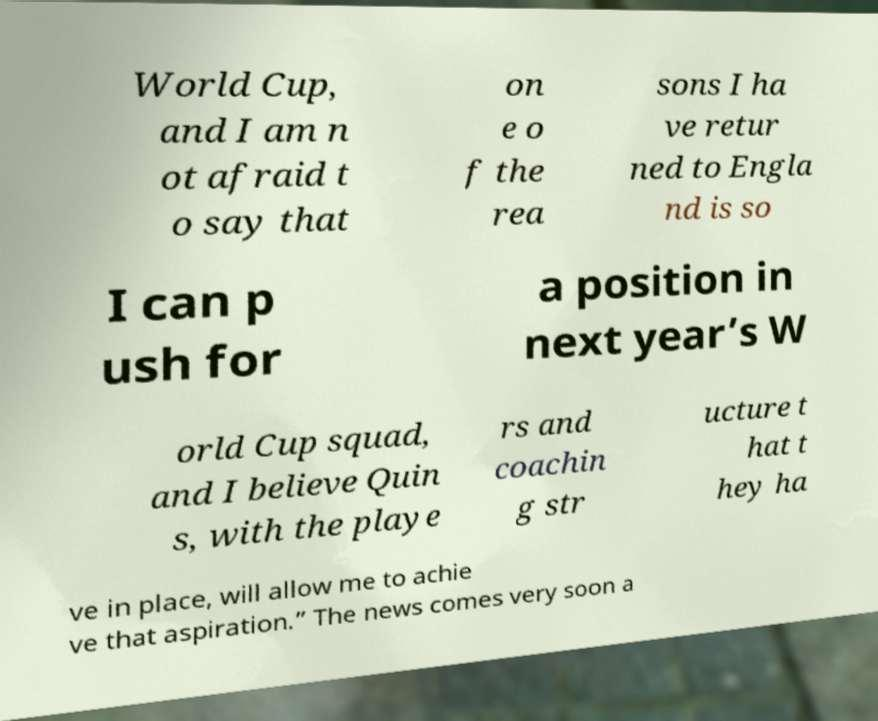I need the written content from this picture converted into text. Can you do that? World Cup, and I am n ot afraid t o say that on e o f the rea sons I ha ve retur ned to Engla nd is so I can p ush for a position in next year’s W orld Cup squad, and I believe Quin s, with the playe rs and coachin g str ucture t hat t hey ha ve in place, will allow me to achie ve that aspiration.” The news comes very soon a 